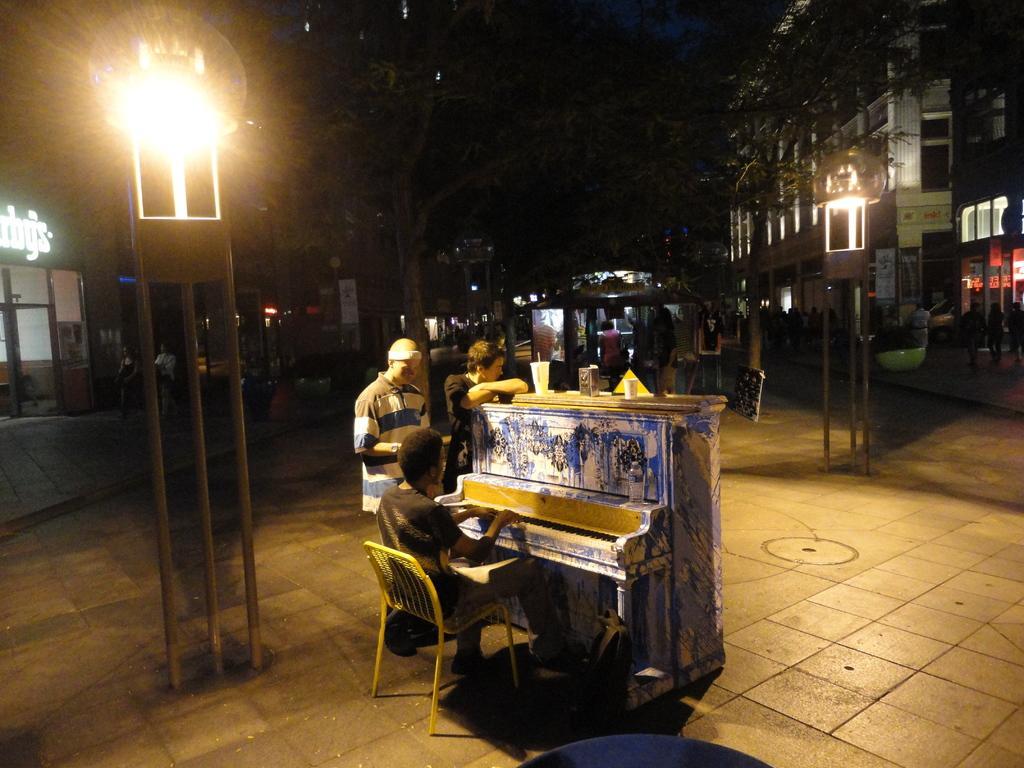Can you describe this image briefly? In this picture we can see a person sitting on a chair and playing a piano, glasses and two men standing on the ground, trees, buildings and in the background it is dark. 